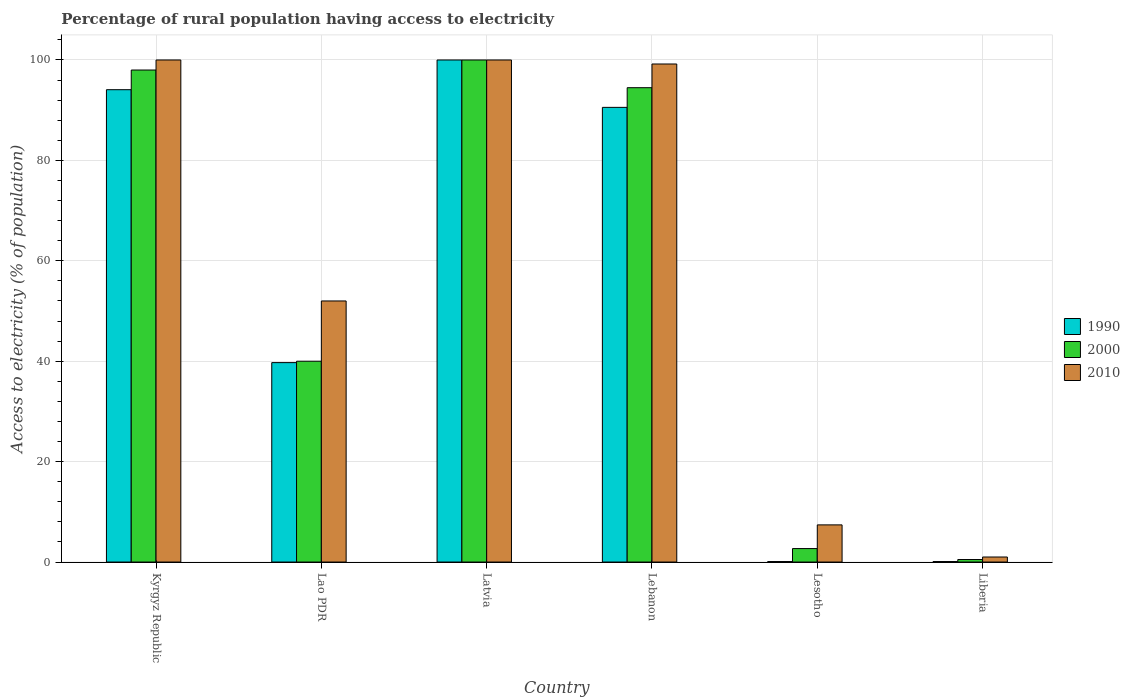How many bars are there on the 4th tick from the left?
Your response must be concise. 3. What is the label of the 1st group of bars from the left?
Offer a very short reply. Kyrgyz Republic. In how many cases, is the number of bars for a given country not equal to the number of legend labels?
Make the answer very short. 0. Across all countries, what is the maximum percentage of rural population having access to electricity in 2000?
Offer a terse response. 100. In which country was the percentage of rural population having access to electricity in 2010 maximum?
Your answer should be compact. Kyrgyz Republic. In which country was the percentage of rural population having access to electricity in 2010 minimum?
Offer a very short reply. Liberia. What is the total percentage of rural population having access to electricity in 2010 in the graph?
Your response must be concise. 359.6. What is the difference between the percentage of rural population having access to electricity in 2010 in Lao PDR and that in Lesotho?
Give a very brief answer. 44.6. What is the difference between the percentage of rural population having access to electricity in 1990 in Liberia and the percentage of rural population having access to electricity in 2010 in Lebanon?
Make the answer very short. -99.1. What is the average percentage of rural population having access to electricity in 2010 per country?
Offer a terse response. 59.93. In how many countries, is the percentage of rural population having access to electricity in 1990 greater than 20 %?
Your answer should be very brief. 4. What is the ratio of the percentage of rural population having access to electricity in 1990 in Lao PDR to that in Lesotho?
Your answer should be compact. 397.2. What is the difference between the highest and the second highest percentage of rural population having access to electricity in 2000?
Ensure brevity in your answer.  -2. What is the difference between the highest and the lowest percentage of rural population having access to electricity in 2000?
Your answer should be compact. 99.5. Is the sum of the percentage of rural population having access to electricity in 2000 in Kyrgyz Republic and Liberia greater than the maximum percentage of rural population having access to electricity in 1990 across all countries?
Ensure brevity in your answer.  No. How many countries are there in the graph?
Make the answer very short. 6. Does the graph contain any zero values?
Make the answer very short. No. Does the graph contain grids?
Give a very brief answer. Yes. Where does the legend appear in the graph?
Your answer should be very brief. Center right. How many legend labels are there?
Provide a short and direct response. 3. What is the title of the graph?
Your answer should be very brief. Percentage of rural population having access to electricity. What is the label or title of the Y-axis?
Make the answer very short. Access to electricity (% of population). What is the Access to electricity (% of population) in 1990 in Kyrgyz Republic?
Ensure brevity in your answer.  94.08. What is the Access to electricity (% of population) in 1990 in Lao PDR?
Offer a very short reply. 39.72. What is the Access to electricity (% of population) of 2000 in Latvia?
Provide a succinct answer. 100. What is the Access to electricity (% of population) of 1990 in Lebanon?
Give a very brief answer. 90.56. What is the Access to electricity (% of population) in 2000 in Lebanon?
Your answer should be very brief. 94.48. What is the Access to electricity (% of population) in 2010 in Lebanon?
Your answer should be very brief. 99.2. What is the Access to electricity (% of population) of 1990 in Lesotho?
Your response must be concise. 0.1. What is the Access to electricity (% of population) of 2000 in Lesotho?
Your answer should be very brief. 2.68. What is the Access to electricity (% of population) of 2010 in Lesotho?
Make the answer very short. 7.4. What is the Access to electricity (% of population) in 1990 in Liberia?
Offer a very short reply. 0.1. Across all countries, what is the minimum Access to electricity (% of population) of 1990?
Provide a short and direct response. 0.1. What is the total Access to electricity (% of population) in 1990 in the graph?
Provide a short and direct response. 324.56. What is the total Access to electricity (% of population) in 2000 in the graph?
Provide a short and direct response. 335.66. What is the total Access to electricity (% of population) of 2010 in the graph?
Keep it short and to the point. 359.6. What is the difference between the Access to electricity (% of population) of 1990 in Kyrgyz Republic and that in Lao PDR?
Provide a short and direct response. 54.36. What is the difference between the Access to electricity (% of population) of 2010 in Kyrgyz Republic and that in Lao PDR?
Keep it short and to the point. 48. What is the difference between the Access to electricity (% of population) of 1990 in Kyrgyz Republic and that in Latvia?
Give a very brief answer. -5.92. What is the difference between the Access to electricity (% of population) of 2010 in Kyrgyz Republic and that in Latvia?
Your response must be concise. 0. What is the difference between the Access to electricity (% of population) in 1990 in Kyrgyz Republic and that in Lebanon?
Keep it short and to the point. 3.52. What is the difference between the Access to electricity (% of population) of 2000 in Kyrgyz Republic and that in Lebanon?
Ensure brevity in your answer.  3.52. What is the difference between the Access to electricity (% of population) in 1990 in Kyrgyz Republic and that in Lesotho?
Keep it short and to the point. 93.98. What is the difference between the Access to electricity (% of population) in 2000 in Kyrgyz Republic and that in Lesotho?
Make the answer very short. 95.32. What is the difference between the Access to electricity (% of population) of 2010 in Kyrgyz Republic and that in Lesotho?
Make the answer very short. 92.6. What is the difference between the Access to electricity (% of population) in 1990 in Kyrgyz Republic and that in Liberia?
Keep it short and to the point. 93.98. What is the difference between the Access to electricity (% of population) in 2000 in Kyrgyz Republic and that in Liberia?
Offer a terse response. 97.5. What is the difference between the Access to electricity (% of population) in 2010 in Kyrgyz Republic and that in Liberia?
Your answer should be very brief. 99. What is the difference between the Access to electricity (% of population) of 1990 in Lao PDR and that in Latvia?
Give a very brief answer. -60.28. What is the difference between the Access to electricity (% of population) of 2000 in Lao PDR and that in Latvia?
Give a very brief answer. -60. What is the difference between the Access to electricity (% of population) in 2010 in Lao PDR and that in Latvia?
Provide a short and direct response. -48. What is the difference between the Access to electricity (% of population) in 1990 in Lao PDR and that in Lebanon?
Give a very brief answer. -50.84. What is the difference between the Access to electricity (% of population) in 2000 in Lao PDR and that in Lebanon?
Provide a short and direct response. -54.48. What is the difference between the Access to electricity (% of population) of 2010 in Lao PDR and that in Lebanon?
Provide a succinct answer. -47.2. What is the difference between the Access to electricity (% of population) of 1990 in Lao PDR and that in Lesotho?
Provide a short and direct response. 39.62. What is the difference between the Access to electricity (% of population) of 2000 in Lao PDR and that in Lesotho?
Offer a very short reply. 37.32. What is the difference between the Access to electricity (% of population) of 2010 in Lao PDR and that in Lesotho?
Your answer should be very brief. 44.6. What is the difference between the Access to electricity (% of population) in 1990 in Lao PDR and that in Liberia?
Offer a very short reply. 39.62. What is the difference between the Access to electricity (% of population) of 2000 in Lao PDR and that in Liberia?
Keep it short and to the point. 39.5. What is the difference between the Access to electricity (% of population) of 2010 in Lao PDR and that in Liberia?
Ensure brevity in your answer.  51. What is the difference between the Access to electricity (% of population) in 1990 in Latvia and that in Lebanon?
Make the answer very short. 9.44. What is the difference between the Access to electricity (% of population) of 2000 in Latvia and that in Lebanon?
Your answer should be compact. 5.52. What is the difference between the Access to electricity (% of population) of 1990 in Latvia and that in Lesotho?
Your response must be concise. 99.9. What is the difference between the Access to electricity (% of population) of 2000 in Latvia and that in Lesotho?
Give a very brief answer. 97.32. What is the difference between the Access to electricity (% of population) in 2010 in Latvia and that in Lesotho?
Provide a short and direct response. 92.6. What is the difference between the Access to electricity (% of population) of 1990 in Latvia and that in Liberia?
Give a very brief answer. 99.9. What is the difference between the Access to electricity (% of population) in 2000 in Latvia and that in Liberia?
Make the answer very short. 99.5. What is the difference between the Access to electricity (% of population) of 1990 in Lebanon and that in Lesotho?
Give a very brief answer. 90.46. What is the difference between the Access to electricity (% of population) of 2000 in Lebanon and that in Lesotho?
Ensure brevity in your answer.  91.8. What is the difference between the Access to electricity (% of population) in 2010 in Lebanon and that in Lesotho?
Give a very brief answer. 91.8. What is the difference between the Access to electricity (% of population) in 1990 in Lebanon and that in Liberia?
Ensure brevity in your answer.  90.46. What is the difference between the Access to electricity (% of population) in 2000 in Lebanon and that in Liberia?
Offer a terse response. 93.98. What is the difference between the Access to electricity (% of population) in 2010 in Lebanon and that in Liberia?
Ensure brevity in your answer.  98.2. What is the difference between the Access to electricity (% of population) of 1990 in Lesotho and that in Liberia?
Keep it short and to the point. 0. What is the difference between the Access to electricity (% of population) in 2000 in Lesotho and that in Liberia?
Ensure brevity in your answer.  2.18. What is the difference between the Access to electricity (% of population) of 2010 in Lesotho and that in Liberia?
Provide a succinct answer. 6.4. What is the difference between the Access to electricity (% of population) in 1990 in Kyrgyz Republic and the Access to electricity (% of population) in 2000 in Lao PDR?
Keep it short and to the point. 54.08. What is the difference between the Access to electricity (% of population) in 1990 in Kyrgyz Republic and the Access to electricity (% of population) in 2010 in Lao PDR?
Ensure brevity in your answer.  42.08. What is the difference between the Access to electricity (% of population) in 1990 in Kyrgyz Republic and the Access to electricity (% of population) in 2000 in Latvia?
Provide a short and direct response. -5.92. What is the difference between the Access to electricity (% of population) of 1990 in Kyrgyz Republic and the Access to electricity (% of population) of 2010 in Latvia?
Give a very brief answer. -5.92. What is the difference between the Access to electricity (% of population) of 2000 in Kyrgyz Republic and the Access to electricity (% of population) of 2010 in Latvia?
Provide a succinct answer. -2. What is the difference between the Access to electricity (% of population) in 1990 in Kyrgyz Republic and the Access to electricity (% of population) in 2000 in Lebanon?
Offer a terse response. -0.4. What is the difference between the Access to electricity (% of population) in 1990 in Kyrgyz Republic and the Access to electricity (% of population) in 2010 in Lebanon?
Your answer should be very brief. -5.12. What is the difference between the Access to electricity (% of population) in 2000 in Kyrgyz Republic and the Access to electricity (% of population) in 2010 in Lebanon?
Offer a terse response. -1.2. What is the difference between the Access to electricity (% of population) in 1990 in Kyrgyz Republic and the Access to electricity (% of population) in 2000 in Lesotho?
Your answer should be compact. 91.4. What is the difference between the Access to electricity (% of population) in 1990 in Kyrgyz Republic and the Access to electricity (% of population) in 2010 in Lesotho?
Make the answer very short. 86.68. What is the difference between the Access to electricity (% of population) of 2000 in Kyrgyz Republic and the Access to electricity (% of population) of 2010 in Lesotho?
Make the answer very short. 90.6. What is the difference between the Access to electricity (% of population) in 1990 in Kyrgyz Republic and the Access to electricity (% of population) in 2000 in Liberia?
Offer a very short reply. 93.58. What is the difference between the Access to electricity (% of population) of 1990 in Kyrgyz Republic and the Access to electricity (% of population) of 2010 in Liberia?
Provide a short and direct response. 93.08. What is the difference between the Access to electricity (% of population) of 2000 in Kyrgyz Republic and the Access to electricity (% of population) of 2010 in Liberia?
Ensure brevity in your answer.  97. What is the difference between the Access to electricity (% of population) of 1990 in Lao PDR and the Access to electricity (% of population) of 2000 in Latvia?
Keep it short and to the point. -60.28. What is the difference between the Access to electricity (% of population) in 1990 in Lao PDR and the Access to electricity (% of population) in 2010 in Latvia?
Your answer should be compact. -60.28. What is the difference between the Access to electricity (% of population) of 2000 in Lao PDR and the Access to electricity (% of population) of 2010 in Latvia?
Keep it short and to the point. -60. What is the difference between the Access to electricity (% of population) in 1990 in Lao PDR and the Access to electricity (% of population) in 2000 in Lebanon?
Ensure brevity in your answer.  -54.76. What is the difference between the Access to electricity (% of population) of 1990 in Lao PDR and the Access to electricity (% of population) of 2010 in Lebanon?
Keep it short and to the point. -59.48. What is the difference between the Access to electricity (% of population) of 2000 in Lao PDR and the Access to electricity (% of population) of 2010 in Lebanon?
Give a very brief answer. -59.2. What is the difference between the Access to electricity (% of population) in 1990 in Lao PDR and the Access to electricity (% of population) in 2000 in Lesotho?
Offer a very short reply. 37.04. What is the difference between the Access to electricity (% of population) of 1990 in Lao PDR and the Access to electricity (% of population) of 2010 in Lesotho?
Make the answer very short. 32.32. What is the difference between the Access to electricity (% of population) in 2000 in Lao PDR and the Access to electricity (% of population) in 2010 in Lesotho?
Offer a terse response. 32.6. What is the difference between the Access to electricity (% of population) in 1990 in Lao PDR and the Access to electricity (% of population) in 2000 in Liberia?
Offer a very short reply. 39.22. What is the difference between the Access to electricity (% of population) of 1990 in Lao PDR and the Access to electricity (% of population) of 2010 in Liberia?
Make the answer very short. 38.72. What is the difference between the Access to electricity (% of population) in 1990 in Latvia and the Access to electricity (% of population) in 2000 in Lebanon?
Offer a terse response. 5.52. What is the difference between the Access to electricity (% of population) in 1990 in Latvia and the Access to electricity (% of population) in 2010 in Lebanon?
Provide a succinct answer. 0.8. What is the difference between the Access to electricity (% of population) of 2000 in Latvia and the Access to electricity (% of population) of 2010 in Lebanon?
Provide a succinct answer. 0.8. What is the difference between the Access to electricity (% of population) of 1990 in Latvia and the Access to electricity (% of population) of 2000 in Lesotho?
Your answer should be very brief. 97.32. What is the difference between the Access to electricity (% of population) of 1990 in Latvia and the Access to electricity (% of population) of 2010 in Lesotho?
Offer a terse response. 92.6. What is the difference between the Access to electricity (% of population) in 2000 in Latvia and the Access to electricity (% of population) in 2010 in Lesotho?
Provide a succinct answer. 92.6. What is the difference between the Access to electricity (% of population) in 1990 in Latvia and the Access to electricity (% of population) in 2000 in Liberia?
Offer a terse response. 99.5. What is the difference between the Access to electricity (% of population) in 2000 in Latvia and the Access to electricity (% of population) in 2010 in Liberia?
Your answer should be compact. 99. What is the difference between the Access to electricity (% of population) in 1990 in Lebanon and the Access to electricity (% of population) in 2000 in Lesotho?
Keep it short and to the point. 87.88. What is the difference between the Access to electricity (% of population) in 1990 in Lebanon and the Access to electricity (% of population) in 2010 in Lesotho?
Give a very brief answer. 83.16. What is the difference between the Access to electricity (% of population) in 2000 in Lebanon and the Access to electricity (% of population) in 2010 in Lesotho?
Make the answer very short. 87.08. What is the difference between the Access to electricity (% of population) of 1990 in Lebanon and the Access to electricity (% of population) of 2000 in Liberia?
Provide a short and direct response. 90.06. What is the difference between the Access to electricity (% of population) in 1990 in Lebanon and the Access to electricity (% of population) in 2010 in Liberia?
Make the answer very short. 89.56. What is the difference between the Access to electricity (% of population) in 2000 in Lebanon and the Access to electricity (% of population) in 2010 in Liberia?
Ensure brevity in your answer.  93.48. What is the difference between the Access to electricity (% of population) in 1990 in Lesotho and the Access to electricity (% of population) in 2000 in Liberia?
Ensure brevity in your answer.  -0.4. What is the difference between the Access to electricity (% of population) in 1990 in Lesotho and the Access to electricity (% of population) in 2010 in Liberia?
Give a very brief answer. -0.9. What is the difference between the Access to electricity (% of population) in 2000 in Lesotho and the Access to electricity (% of population) in 2010 in Liberia?
Your response must be concise. 1.68. What is the average Access to electricity (% of population) of 1990 per country?
Ensure brevity in your answer.  54.09. What is the average Access to electricity (% of population) in 2000 per country?
Make the answer very short. 55.94. What is the average Access to electricity (% of population) in 2010 per country?
Make the answer very short. 59.93. What is the difference between the Access to electricity (% of population) of 1990 and Access to electricity (% of population) of 2000 in Kyrgyz Republic?
Provide a succinct answer. -3.92. What is the difference between the Access to electricity (% of population) in 1990 and Access to electricity (% of population) in 2010 in Kyrgyz Republic?
Provide a short and direct response. -5.92. What is the difference between the Access to electricity (% of population) of 1990 and Access to electricity (% of population) of 2000 in Lao PDR?
Your answer should be very brief. -0.28. What is the difference between the Access to electricity (% of population) in 1990 and Access to electricity (% of population) in 2010 in Lao PDR?
Make the answer very short. -12.28. What is the difference between the Access to electricity (% of population) of 2000 and Access to electricity (% of population) of 2010 in Lao PDR?
Your answer should be compact. -12. What is the difference between the Access to electricity (% of population) of 1990 and Access to electricity (% of population) of 2000 in Lebanon?
Ensure brevity in your answer.  -3.92. What is the difference between the Access to electricity (% of population) in 1990 and Access to electricity (% of population) in 2010 in Lebanon?
Keep it short and to the point. -8.64. What is the difference between the Access to electricity (% of population) in 2000 and Access to electricity (% of population) in 2010 in Lebanon?
Your response must be concise. -4.72. What is the difference between the Access to electricity (% of population) of 1990 and Access to electricity (% of population) of 2000 in Lesotho?
Keep it short and to the point. -2.58. What is the difference between the Access to electricity (% of population) of 2000 and Access to electricity (% of population) of 2010 in Lesotho?
Your answer should be very brief. -4.72. What is the difference between the Access to electricity (% of population) of 1990 and Access to electricity (% of population) of 2000 in Liberia?
Make the answer very short. -0.4. What is the difference between the Access to electricity (% of population) in 1990 and Access to electricity (% of population) in 2010 in Liberia?
Make the answer very short. -0.9. What is the difference between the Access to electricity (% of population) of 2000 and Access to electricity (% of population) of 2010 in Liberia?
Provide a succinct answer. -0.5. What is the ratio of the Access to electricity (% of population) of 1990 in Kyrgyz Republic to that in Lao PDR?
Ensure brevity in your answer.  2.37. What is the ratio of the Access to electricity (% of population) in 2000 in Kyrgyz Republic to that in Lao PDR?
Keep it short and to the point. 2.45. What is the ratio of the Access to electricity (% of population) of 2010 in Kyrgyz Republic to that in Lao PDR?
Your answer should be compact. 1.92. What is the ratio of the Access to electricity (% of population) in 1990 in Kyrgyz Republic to that in Latvia?
Give a very brief answer. 0.94. What is the ratio of the Access to electricity (% of population) of 2000 in Kyrgyz Republic to that in Latvia?
Give a very brief answer. 0.98. What is the ratio of the Access to electricity (% of population) of 1990 in Kyrgyz Republic to that in Lebanon?
Offer a terse response. 1.04. What is the ratio of the Access to electricity (% of population) of 2000 in Kyrgyz Republic to that in Lebanon?
Make the answer very short. 1.04. What is the ratio of the Access to electricity (% of population) in 1990 in Kyrgyz Republic to that in Lesotho?
Keep it short and to the point. 940.79. What is the ratio of the Access to electricity (% of population) of 2000 in Kyrgyz Republic to that in Lesotho?
Your response must be concise. 36.56. What is the ratio of the Access to electricity (% of population) of 2010 in Kyrgyz Republic to that in Lesotho?
Give a very brief answer. 13.51. What is the ratio of the Access to electricity (% of population) in 1990 in Kyrgyz Republic to that in Liberia?
Offer a very short reply. 940.79. What is the ratio of the Access to electricity (% of population) of 2000 in Kyrgyz Republic to that in Liberia?
Make the answer very short. 196. What is the ratio of the Access to electricity (% of population) in 1990 in Lao PDR to that in Latvia?
Your answer should be compact. 0.4. What is the ratio of the Access to electricity (% of population) in 2000 in Lao PDR to that in Latvia?
Provide a succinct answer. 0.4. What is the ratio of the Access to electricity (% of population) in 2010 in Lao PDR to that in Latvia?
Offer a terse response. 0.52. What is the ratio of the Access to electricity (% of population) of 1990 in Lao PDR to that in Lebanon?
Your response must be concise. 0.44. What is the ratio of the Access to electricity (% of population) of 2000 in Lao PDR to that in Lebanon?
Your response must be concise. 0.42. What is the ratio of the Access to electricity (% of population) of 2010 in Lao PDR to that in Lebanon?
Your answer should be very brief. 0.52. What is the ratio of the Access to electricity (% of population) in 1990 in Lao PDR to that in Lesotho?
Keep it short and to the point. 397.2. What is the ratio of the Access to electricity (% of population) in 2000 in Lao PDR to that in Lesotho?
Your answer should be compact. 14.92. What is the ratio of the Access to electricity (% of population) in 2010 in Lao PDR to that in Lesotho?
Ensure brevity in your answer.  7.03. What is the ratio of the Access to electricity (% of population) of 1990 in Lao PDR to that in Liberia?
Ensure brevity in your answer.  397.2. What is the ratio of the Access to electricity (% of population) in 2010 in Lao PDR to that in Liberia?
Give a very brief answer. 52. What is the ratio of the Access to electricity (% of population) of 1990 in Latvia to that in Lebanon?
Give a very brief answer. 1.1. What is the ratio of the Access to electricity (% of population) of 2000 in Latvia to that in Lebanon?
Offer a very short reply. 1.06. What is the ratio of the Access to electricity (% of population) of 2010 in Latvia to that in Lebanon?
Your answer should be compact. 1.01. What is the ratio of the Access to electricity (% of population) of 2000 in Latvia to that in Lesotho?
Give a very brief answer. 37.3. What is the ratio of the Access to electricity (% of population) of 2010 in Latvia to that in Lesotho?
Your answer should be very brief. 13.51. What is the ratio of the Access to electricity (% of population) of 1990 in Latvia to that in Liberia?
Give a very brief answer. 1000. What is the ratio of the Access to electricity (% of population) in 2010 in Latvia to that in Liberia?
Provide a short and direct response. 100. What is the ratio of the Access to electricity (% of population) of 1990 in Lebanon to that in Lesotho?
Offer a terse response. 905.6. What is the ratio of the Access to electricity (% of population) of 2000 in Lebanon to that in Lesotho?
Provide a short and direct response. 35.25. What is the ratio of the Access to electricity (% of population) of 2010 in Lebanon to that in Lesotho?
Your answer should be very brief. 13.41. What is the ratio of the Access to electricity (% of population) in 1990 in Lebanon to that in Liberia?
Your answer should be very brief. 905.6. What is the ratio of the Access to electricity (% of population) of 2000 in Lebanon to that in Liberia?
Give a very brief answer. 188.96. What is the ratio of the Access to electricity (% of population) in 2010 in Lebanon to that in Liberia?
Offer a terse response. 99.2. What is the ratio of the Access to electricity (% of population) in 1990 in Lesotho to that in Liberia?
Your response must be concise. 1. What is the ratio of the Access to electricity (% of population) in 2000 in Lesotho to that in Liberia?
Provide a short and direct response. 5.36. What is the ratio of the Access to electricity (% of population) of 2010 in Lesotho to that in Liberia?
Make the answer very short. 7.4. What is the difference between the highest and the second highest Access to electricity (% of population) of 1990?
Provide a succinct answer. 5.92. What is the difference between the highest and the lowest Access to electricity (% of population) of 1990?
Your answer should be compact. 99.9. What is the difference between the highest and the lowest Access to electricity (% of population) in 2000?
Your answer should be very brief. 99.5. 